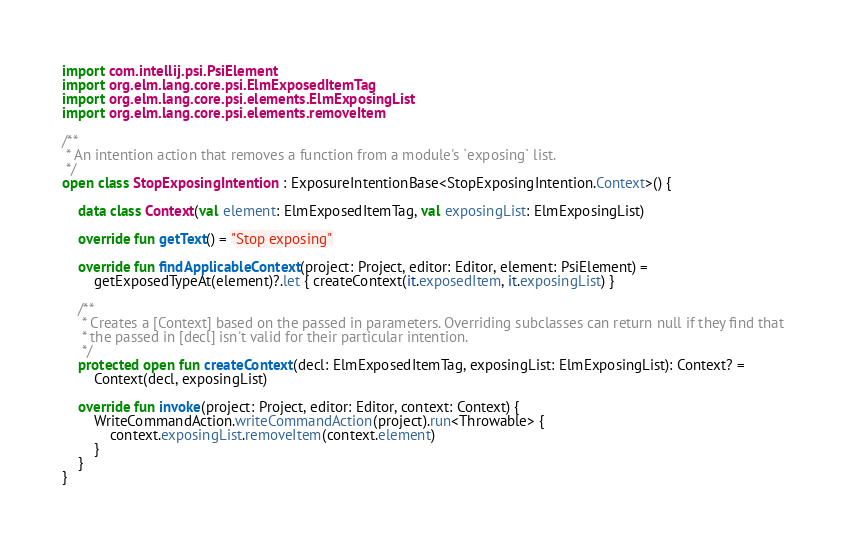<code> <loc_0><loc_0><loc_500><loc_500><_Kotlin_>import com.intellij.psi.PsiElement
import org.elm.lang.core.psi.ElmExposedItemTag
import org.elm.lang.core.psi.elements.ElmExposingList
import org.elm.lang.core.psi.elements.removeItem

/**
 * An intention action that removes a function from a module's `exposing` list.
 */
open class StopExposingIntention : ExposureIntentionBase<StopExposingIntention.Context>() {

    data class Context(val element: ElmExposedItemTag, val exposingList: ElmExposingList)

    override fun getText() = "Stop exposing"

    override fun findApplicableContext(project: Project, editor: Editor, element: PsiElement) =
        getExposedTypeAt(element)?.let { createContext(it.exposedItem, it.exposingList) }

    /**
     * Creates a [Context] based on the passed in parameters. Overriding subclasses can return null if they find that
     * the passed in [decl] isn't valid for their particular intention.
     */
    protected open fun createContext(decl: ElmExposedItemTag, exposingList: ElmExposingList): Context? =
        Context(decl, exposingList)

    override fun invoke(project: Project, editor: Editor, context: Context) {
        WriteCommandAction.writeCommandAction(project).run<Throwable> {
            context.exposingList.removeItem(context.element)
        }
    }
}
</code> 